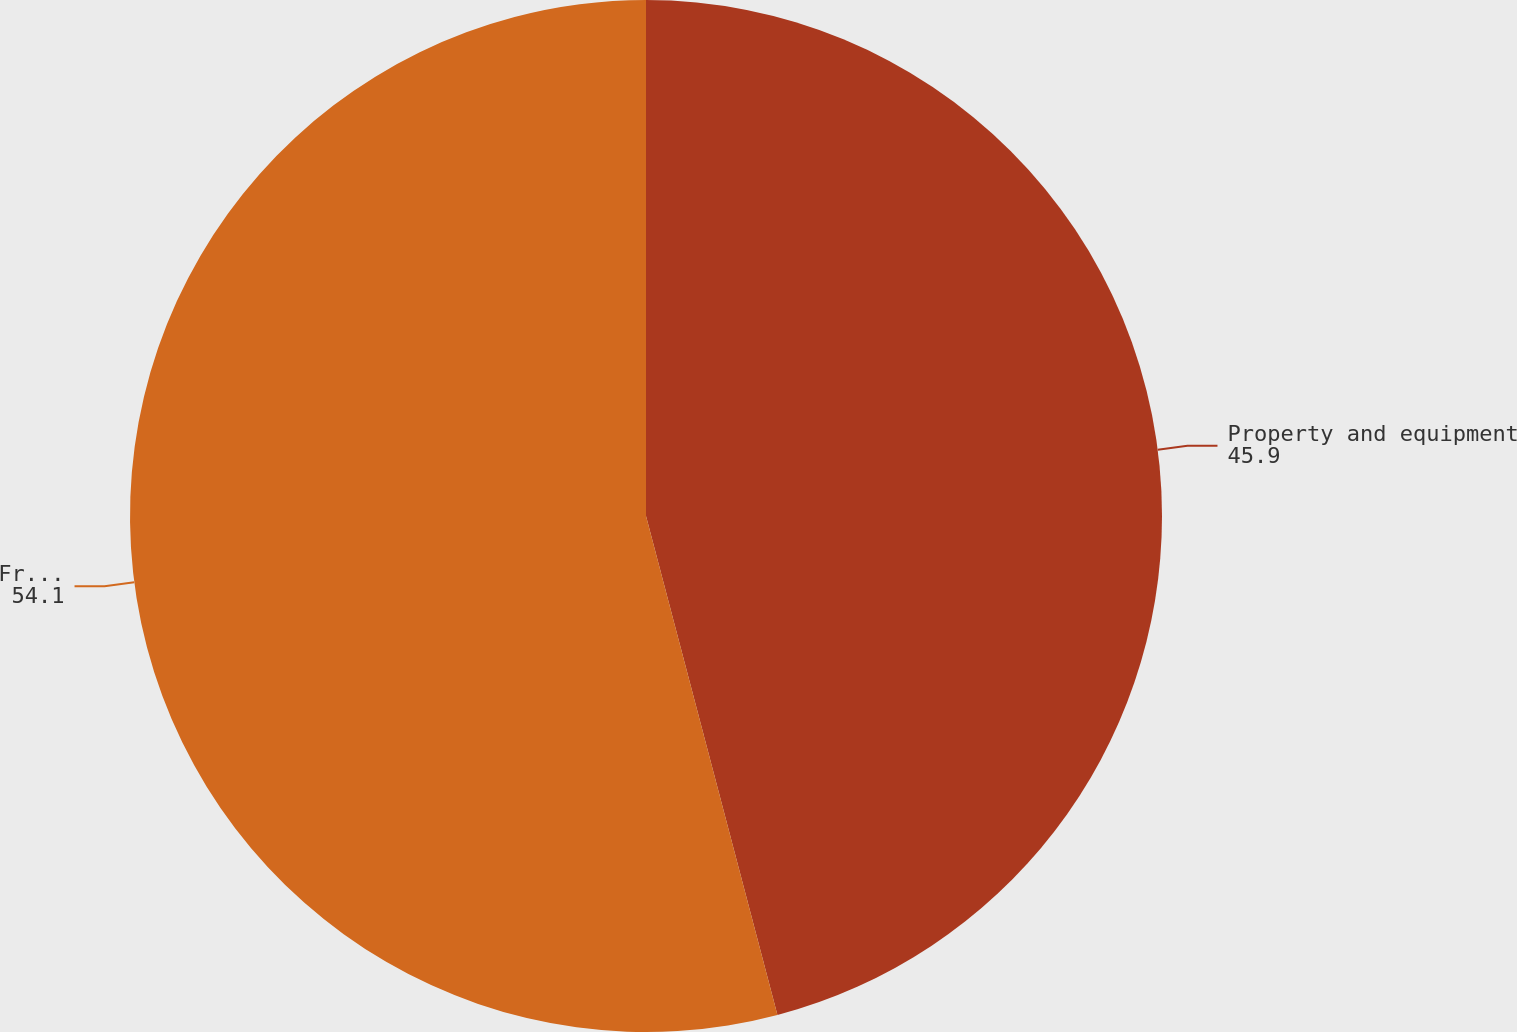Convert chart to OTSL. <chart><loc_0><loc_0><loc_500><loc_500><pie_chart><fcel>Property and equipment<fcel>Free cash flow<nl><fcel>45.9%<fcel>54.1%<nl></chart> 